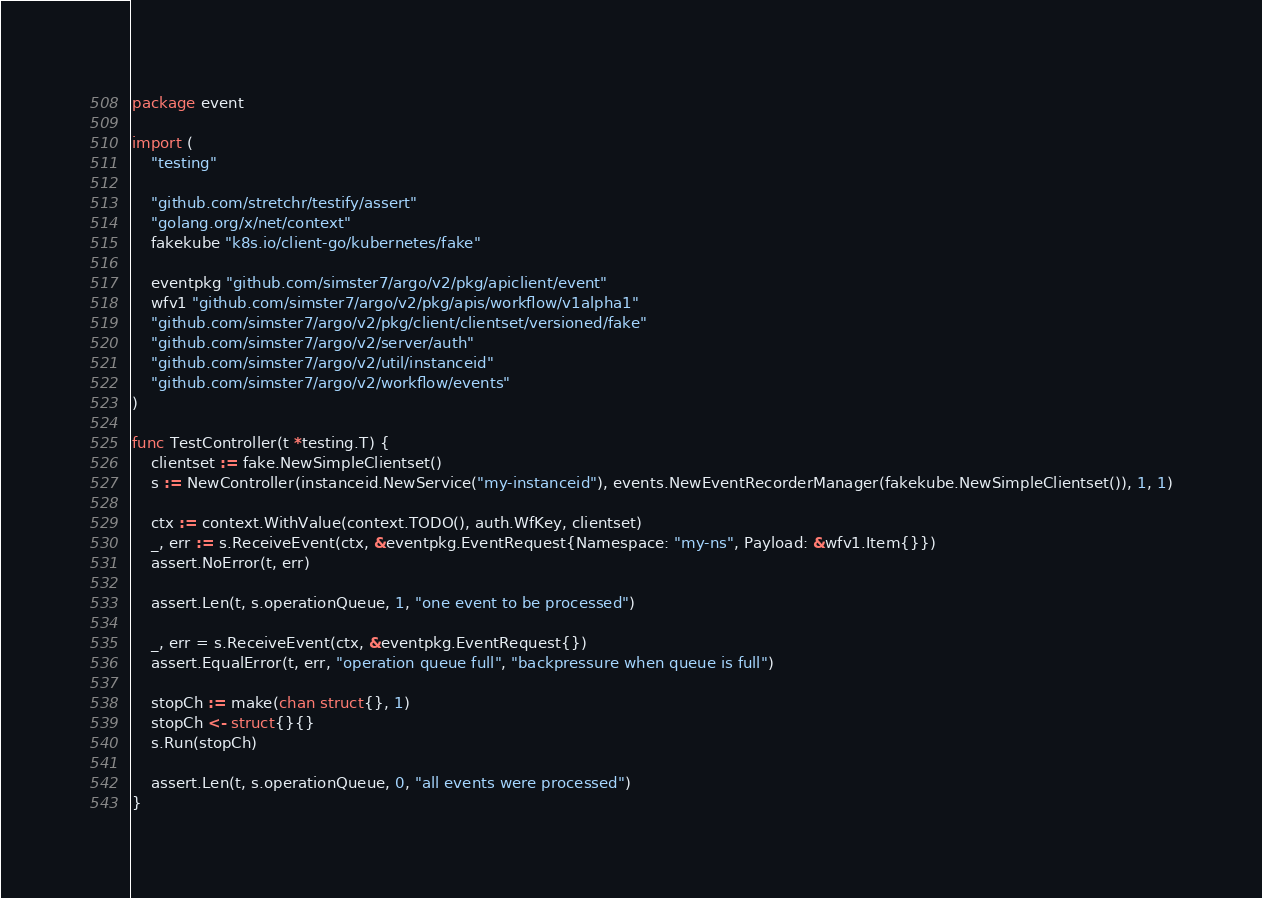Convert code to text. <code><loc_0><loc_0><loc_500><loc_500><_Go_>package event

import (
	"testing"

	"github.com/stretchr/testify/assert"
	"golang.org/x/net/context"
	fakekube "k8s.io/client-go/kubernetes/fake"

	eventpkg "github.com/simster7/argo/v2/pkg/apiclient/event"
	wfv1 "github.com/simster7/argo/v2/pkg/apis/workflow/v1alpha1"
	"github.com/simster7/argo/v2/pkg/client/clientset/versioned/fake"
	"github.com/simster7/argo/v2/server/auth"
	"github.com/simster7/argo/v2/util/instanceid"
	"github.com/simster7/argo/v2/workflow/events"
)

func TestController(t *testing.T) {
	clientset := fake.NewSimpleClientset()
	s := NewController(instanceid.NewService("my-instanceid"), events.NewEventRecorderManager(fakekube.NewSimpleClientset()), 1, 1)

	ctx := context.WithValue(context.TODO(), auth.WfKey, clientset)
	_, err := s.ReceiveEvent(ctx, &eventpkg.EventRequest{Namespace: "my-ns", Payload: &wfv1.Item{}})
	assert.NoError(t, err)

	assert.Len(t, s.operationQueue, 1, "one event to be processed")

	_, err = s.ReceiveEvent(ctx, &eventpkg.EventRequest{})
	assert.EqualError(t, err, "operation queue full", "backpressure when queue is full")

	stopCh := make(chan struct{}, 1)
	stopCh <- struct{}{}
	s.Run(stopCh)

	assert.Len(t, s.operationQueue, 0, "all events were processed")
}
</code> 